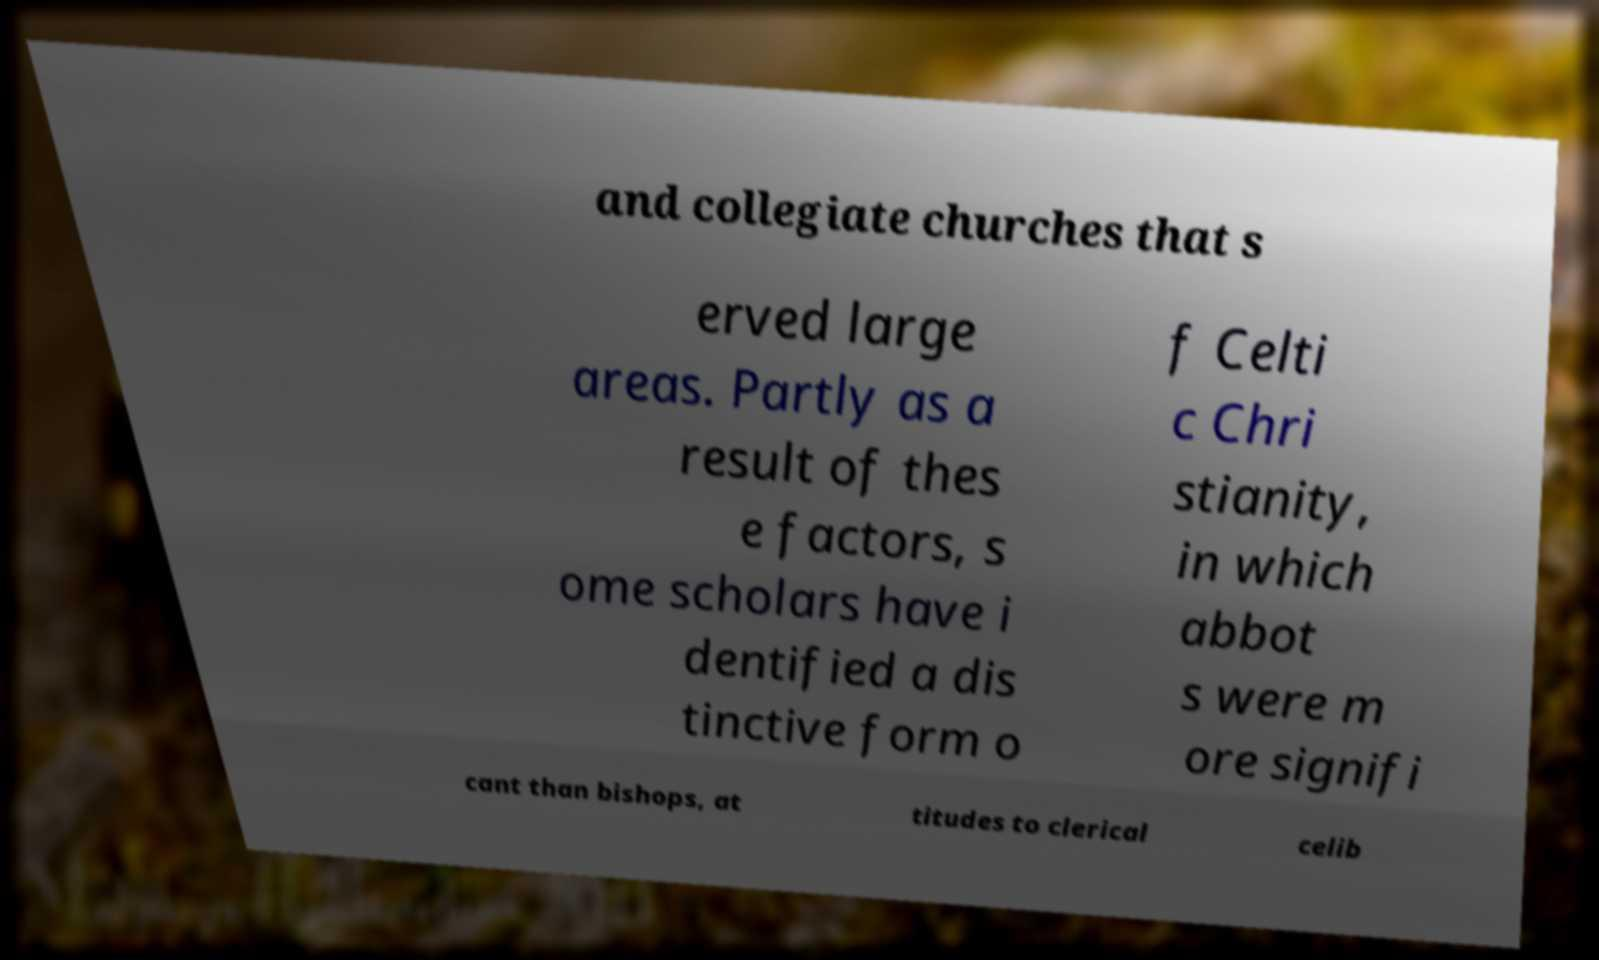Can you read and provide the text displayed in the image?This photo seems to have some interesting text. Can you extract and type it out for me? and collegiate churches that s erved large areas. Partly as a result of thes e factors, s ome scholars have i dentified a dis tinctive form o f Celti c Chri stianity, in which abbot s were m ore signifi cant than bishops, at titudes to clerical celib 